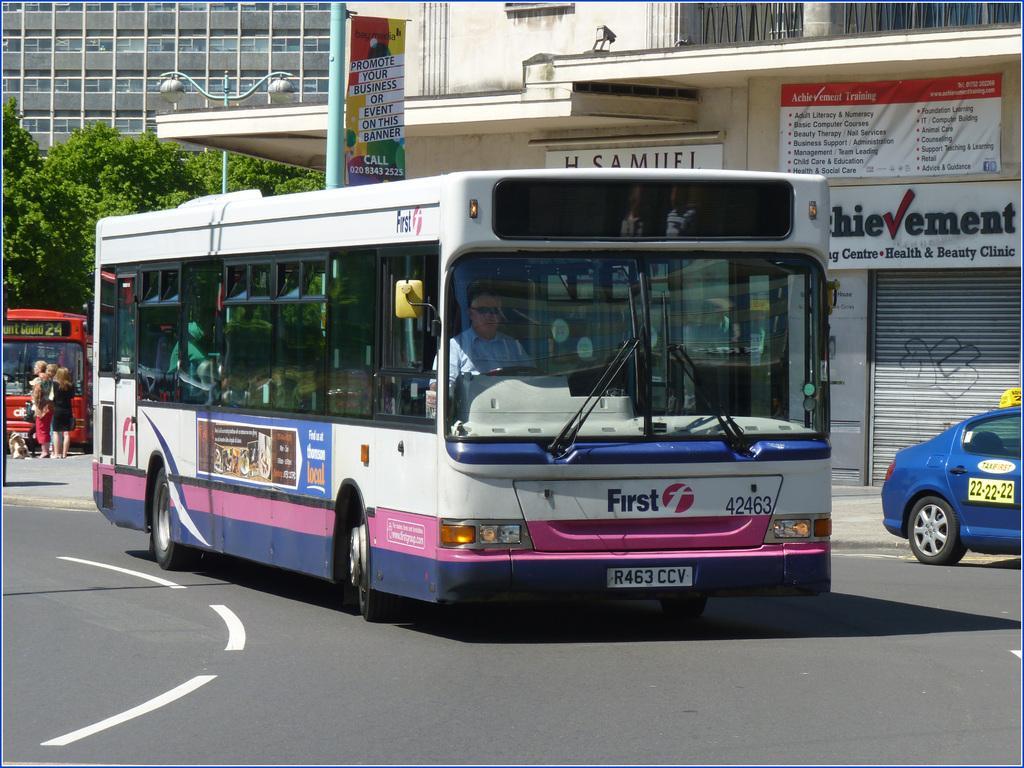How would you summarize this image in a sentence or two? In this image I can see vehicles on the road and a group of people. In the background I can see trees, boards, buildings, windows, light pole and shops. This image is taken may be during a day on the road. 